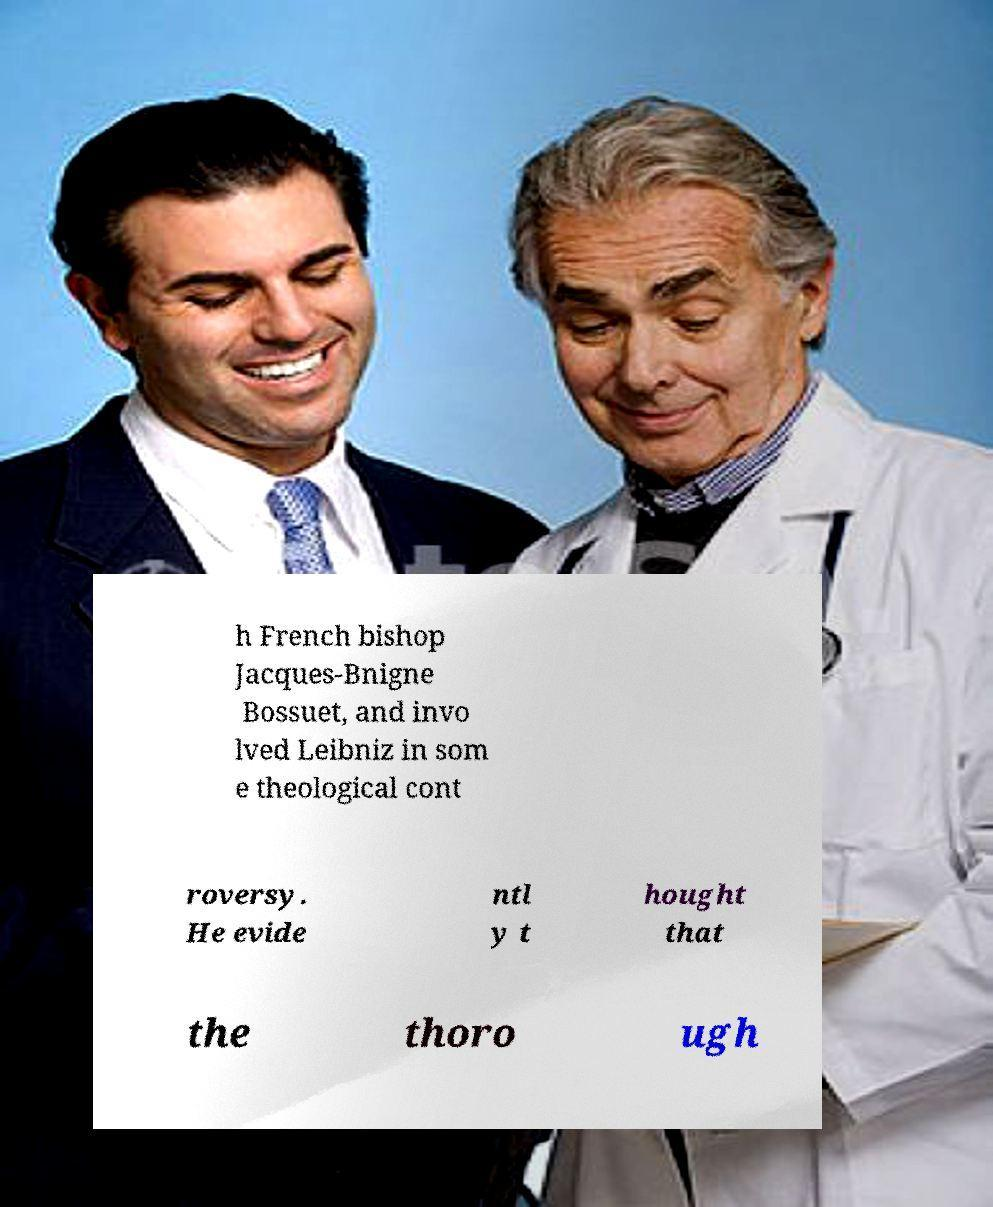Please read and relay the text visible in this image. What does it say? h French bishop Jacques-Bnigne Bossuet, and invo lved Leibniz in som e theological cont roversy. He evide ntl y t hought that the thoro ugh 